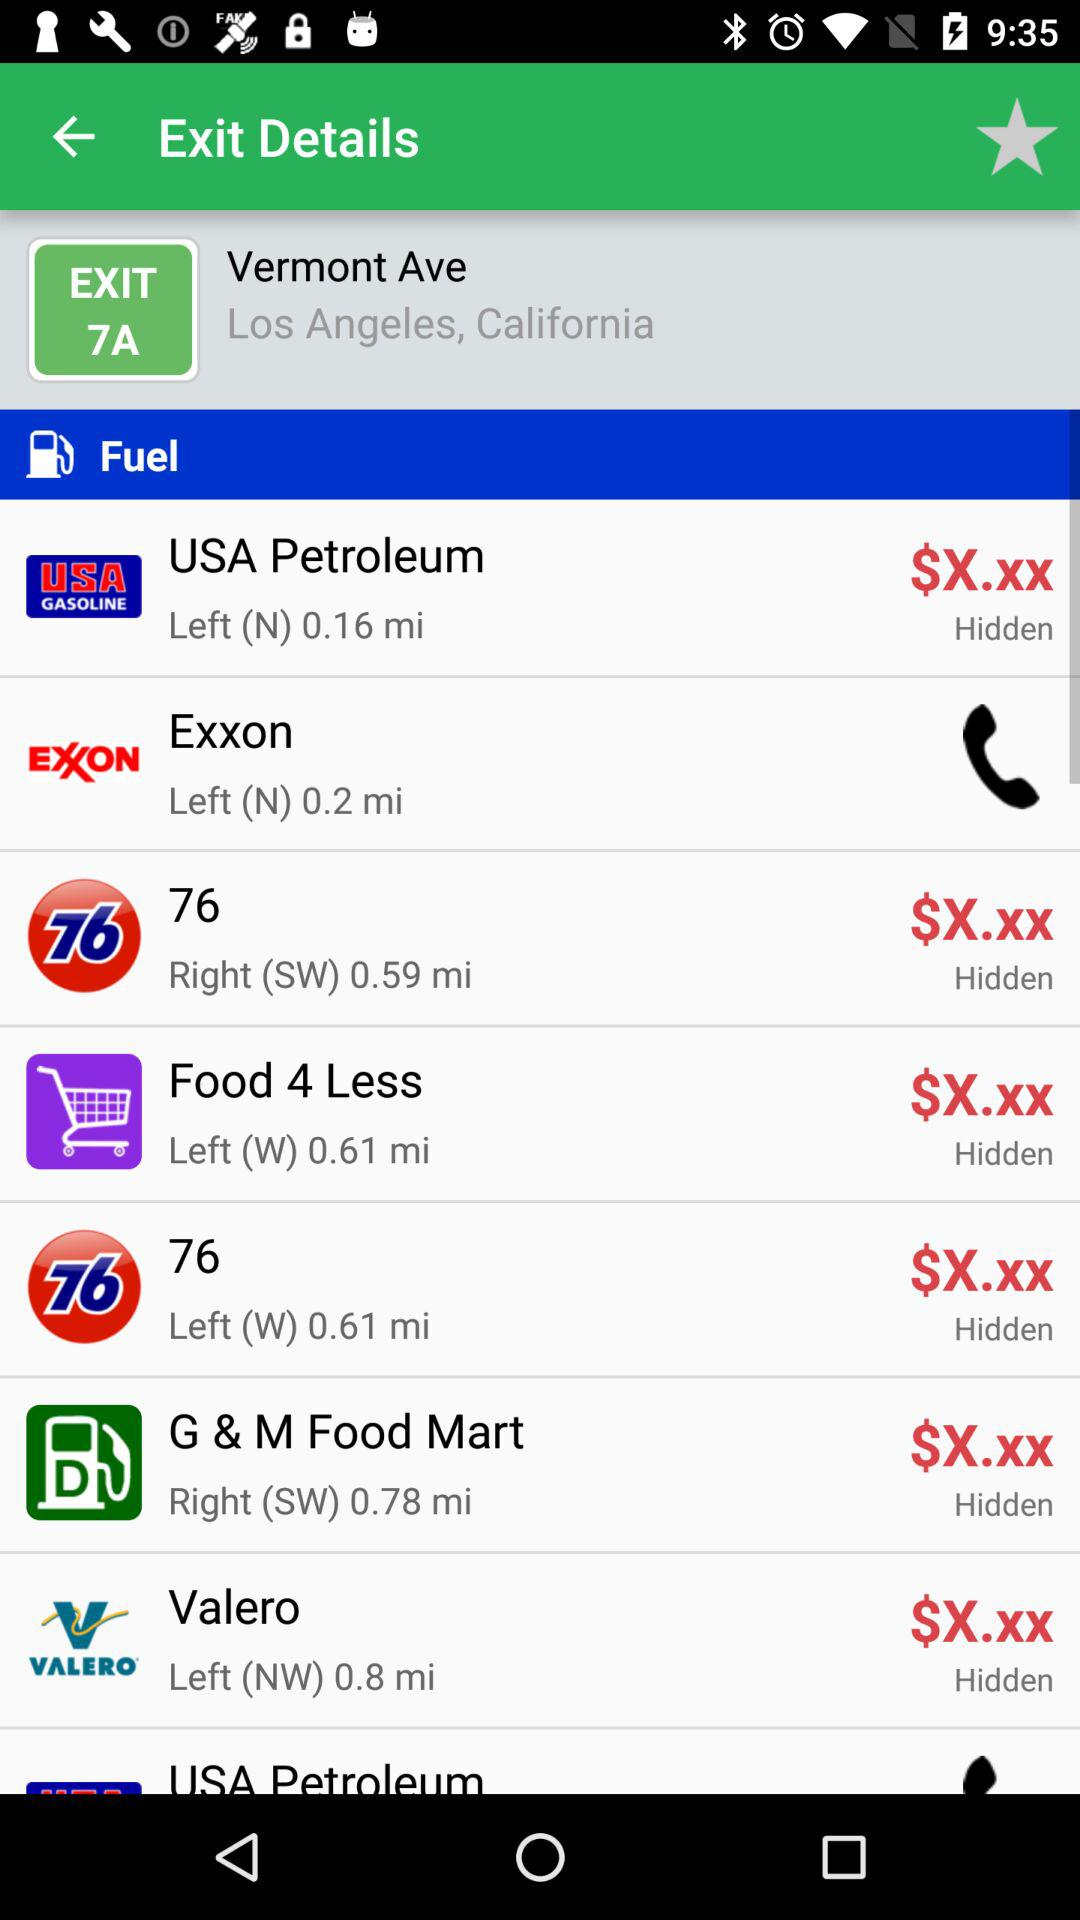What is the location? The location is Los Angeles, California. 